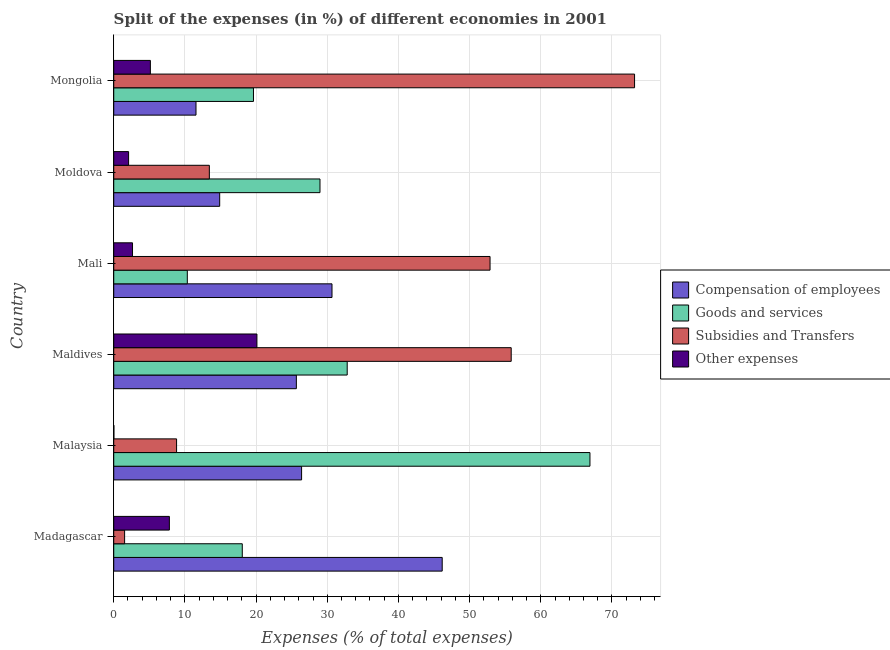How many different coloured bars are there?
Make the answer very short. 4. Are the number of bars per tick equal to the number of legend labels?
Your answer should be compact. Yes. Are the number of bars on each tick of the Y-axis equal?
Offer a terse response. Yes. How many bars are there on the 4th tick from the bottom?
Ensure brevity in your answer.  4. What is the label of the 6th group of bars from the top?
Your answer should be very brief. Madagascar. What is the percentage of amount spent on other expenses in Moldova?
Provide a short and direct response. 2.09. Across all countries, what is the maximum percentage of amount spent on subsidies?
Your answer should be compact. 73.17. Across all countries, what is the minimum percentage of amount spent on goods and services?
Keep it short and to the point. 10.34. In which country was the percentage of amount spent on goods and services maximum?
Make the answer very short. Malaysia. In which country was the percentage of amount spent on other expenses minimum?
Keep it short and to the point. Malaysia. What is the total percentage of amount spent on compensation of employees in the graph?
Keep it short and to the point. 155.3. What is the difference between the percentage of amount spent on goods and services in Malaysia and that in Mali?
Offer a very short reply. 56.57. What is the difference between the percentage of amount spent on other expenses in Malaysia and the percentage of amount spent on subsidies in Maldives?
Ensure brevity in your answer.  -55.82. What is the average percentage of amount spent on other expenses per country?
Your response must be concise. 6.3. What is the difference between the percentage of amount spent on compensation of employees and percentage of amount spent on subsidies in Maldives?
Keep it short and to the point. -30.18. What is the ratio of the percentage of amount spent on goods and services in Maldives to that in Mongolia?
Offer a very short reply. 1.67. Is the difference between the percentage of amount spent on compensation of employees in Madagascar and Mongolia greater than the difference between the percentage of amount spent on goods and services in Madagascar and Mongolia?
Keep it short and to the point. Yes. What is the difference between the highest and the second highest percentage of amount spent on compensation of employees?
Your response must be concise. 15.48. What is the difference between the highest and the lowest percentage of amount spent on compensation of employees?
Your answer should be very brief. 34.59. What does the 3rd bar from the top in Maldives represents?
Your answer should be very brief. Goods and services. What does the 4th bar from the bottom in Maldives represents?
Provide a succinct answer. Other expenses. Are all the bars in the graph horizontal?
Your answer should be compact. Yes. Are the values on the major ticks of X-axis written in scientific E-notation?
Provide a short and direct response. No. Where does the legend appear in the graph?
Your answer should be compact. Center right. How are the legend labels stacked?
Provide a short and direct response. Vertical. What is the title of the graph?
Your answer should be very brief. Split of the expenses (in %) of different economies in 2001. Does "Water" appear as one of the legend labels in the graph?
Give a very brief answer. No. What is the label or title of the X-axis?
Give a very brief answer. Expenses (% of total expenses). What is the Expenses (% of total expenses) of Compensation of employees in Madagascar?
Your answer should be compact. 46.15. What is the Expenses (% of total expenses) of Goods and services in Madagascar?
Provide a succinct answer. 18.06. What is the Expenses (% of total expenses) in Subsidies and Transfers in Madagascar?
Offer a terse response. 1.53. What is the Expenses (% of total expenses) in Other expenses in Madagascar?
Offer a terse response. 7.82. What is the Expenses (% of total expenses) in Compensation of employees in Malaysia?
Make the answer very short. 26.39. What is the Expenses (% of total expenses) in Goods and services in Malaysia?
Offer a very short reply. 66.91. What is the Expenses (% of total expenses) of Subsidies and Transfers in Malaysia?
Ensure brevity in your answer.  8.83. What is the Expenses (% of total expenses) of Other expenses in Malaysia?
Offer a terse response. 0.02. What is the Expenses (% of total expenses) in Compensation of employees in Maldives?
Provide a short and direct response. 25.66. What is the Expenses (% of total expenses) of Goods and services in Maldives?
Offer a very short reply. 32.8. What is the Expenses (% of total expenses) in Subsidies and Transfers in Maldives?
Provide a short and direct response. 55.84. What is the Expenses (% of total expenses) in Other expenses in Maldives?
Your answer should be compact. 20.12. What is the Expenses (% of total expenses) in Compensation of employees in Mali?
Ensure brevity in your answer.  30.66. What is the Expenses (% of total expenses) of Goods and services in Mali?
Make the answer very short. 10.34. What is the Expenses (% of total expenses) in Subsidies and Transfers in Mali?
Your answer should be compact. 52.87. What is the Expenses (% of total expenses) in Other expenses in Mali?
Offer a terse response. 2.64. What is the Expenses (% of total expenses) in Compensation of employees in Moldova?
Your response must be concise. 14.89. What is the Expenses (% of total expenses) in Goods and services in Moldova?
Your response must be concise. 28.98. What is the Expenses (% of total expenses) in Subsidies and Transfers in Moldova?
Keep it short and to the point. 13.43. What is the Expenses (% of total expenses) of Other expenses in Moldova?
Your response must be concise. 2.09. What is the Expenses (% of total expenses) of Compensation of employees in Mongolia?
Make the answer very short. 11.56. What is the Expenses (% of total expenses) in Goods and services in Mongolia?
Make the answer very short. 19.63. What is the Expenses (% of total expenses) in Subsidies and Transfers in Mongolia?
Your answer should be very brief. 73.17. What is the Expenses (% of total expenses) in Other expenses in Mongolia?
Your response must be concise. 5.15. Across all countries, what is the maximum Expenses (% of total expenses) in Compensation of employees?
Provide a short and direct response. 46.15. Across all countries, what is the maximum Expenses (% of total expenses) of Goods and services?
Your answer should be very brief. 66.91. Across all countries, what is the maximum Expenses (% of total expenses) in Subsidies and Transfers?
Your answer should be compact. 73.17. Across all countries, what is the maximum Expenses (% of total expenses) of Other expenses?
Offer a very short reply. 20.12. Across all countries, what is the minimum Expenses (% of total expenses) in Compensation of employees?
Offer a very short reply. 11.56. Across all countries, what is the minimum Expenses (% of total expenses) in Goods and services?
Your answer should be very brief. 10.34. Across all countries, what is the minimum Expenses (% of total expenses) in Subsidies and Transfers?
Offer a very short reply. 1.53. Across all countries, what is the minimum Expenses (% of total expenses) of Other expenses?
Provide a short and direct response. 0.02. What is the total Expenses (% of total expenses) in Compensation of employees in the graph?
Keep it short and to the point. 155.3. What is the total Expenses (% of total expenses) in Goods and services in the graph?
Give a very brief answer. 176.71. What is the total Expenses (% of total expenses) of Subsidies and Transfers in the graph?
Keep it short and to the point. 205.67. What is the total Expenses (% of total expenses) of Other expenses in the graph?
Offer a terse response. 37.82. What is the difference between the Expenses (% of total expenses) in Compensation of employees in Madagascar and that in Malaysia?
Provide a succinct answer. 19.76. What is the difference between the Expenses (% of total expenses) in Goods and services in Madagascar and that in Malaysia?
Offer a very short reply. -48.85. What is the difference between the Expenses (% of total expenses) of Subsidies and Transfers in Madagascar and that in Malaysia?
Offer a very short reply. -7.3. What is the difference between the Expenses (% of total expenses) of Other expenses in Madagascar and that in Malaysia?
Keep it short and to the point. 7.8. What is the difference between the Expenses (% of total expenses) of Compensation of employees in Madagascar and that in Maldives?
Your response must be concise. 20.49. What is the difference between the Expenses (% of total expenses) in Goods and services in Madagascar and that in Maldives?
Make the answer very short. -14.74. What is the difference between the Expenses (% of total expenses) in Subsidies and Transfers in Madagascar and that in Maldives?
Provide a succinct answer. -54.31. What is the difference between the Expenses (% of total expenses) of Other expenses in Madagascar and that in Maldives?
Make the answer very short. -12.3. What is the difference between the Expenses (% of total expenses) of Compensation of employees in Madagascar and that in Mali?
Offer a terse response. 15.48. What is the difference between the Expenses (% of total expenses) of Goods and services in Madagascar and that in Mali?
Offer a terse response. 7.72. What is the difference between the Expenses (% of total expenses) in Subsidies and Transfers in Madagascar and that in Mali?
Offer a very short reply. -51.34. What is the difference between the Expenses (% of total expenses) in Other expenses in Madagascar and that in Mali?
Offer a terse response. 5.18. What is the difference between the Expenses (% of total expenses) in Compensation of employees in Madagascar and that in Moldova?
Provide a short and direct response. 31.26. What is the difference between the Expenses (% of total expenses) in Goods and services in Madagascar and that in Moldova?
Ensure brevity in your answer.  -10.92. What is the difference between the Expenses (% of total expenses) in Subsidies and Transfers in Madagascar and that in Moldova?
Your answer should be very brief. -11.9. What is the difference between the Expenses (% of total expenses) in Other expenses in Madagascar and that in Moldova?
Your answer should be very brief. 5.73. What is the difference between the Expenses (% of total expenses) in Compensation of employees in Madagascar and that in Mongolia?
Provide a short and direct response. 34.59. What is the difference between the Expenses (% of total expenses) in Goods and services in Madagascar and that in Mongolia?
Keep it short and to the point. -1.57. What is the difference between the Expenses (% of total expenses) of Subsidies and Transfers in Madagascar and that in Mongolia?
Ensure brevity in your answer.  -71.65. What is the difference between the Expenses (% of total expenses) in Other expenses in Madagascar and that in Mongolia?
Ensure brevity in your answer.  2.67. What is the difference between the Expenses (% of total expenses) of Compensation of employees in Malaysia and that in Maldives?
Give a very brief answer. 0.73. What is the difference between the Expenses (% of total expenses) in Goods and services in Malaysia and that in Maldives?
Keep it short and to the point. 34.1. What is the difference between the Expenses (% of total expenses) of Subsidies and Transfers in Malaysia and that in Maldives?
Your response must be concise. -47.01. What is the difference between the Expenses (% of total expenses) of Other expenses in Malaysia and that in Maldives?
Your answer should be compact. -20.1. What is the difference between the Expenses (% of total expenses) of Compensation of employees in Malaysia and that in Mali?
Provide a succinct answer. -4.27. What is the difference between the Expenses (% of total expenses) of Goods and services in Malaysia and that in Mali?
Offer a terse response. 56.57. What is the difference between the Expenses (% of total expenses) in Subsidies and Transfers in Malaysia and that in Mali?
Provide a short and direct response. -44.04. What is the difference between the Expenses (% of total expenses) of Other expenses in Malaysia and that in Mali?
Keep it short and to the point. -2.62. What is the difference between the Expenses (% of total expenses) of Compensation of employees in Malaysia and that in Moldova?
Your answer should be very brief. 11.51. What is the difference between the Expenses (% of total expenses) of Goods and services in Malaysia and that in Moldova?
Provide a short and direct response. 37.93. What is the difference between the Expenses (% of total expenses) of Subsidies and Transfers in Malaysia and that in Moldova?
Your response must be concise. -4.6. What is the difference between the Expenses (% of total expenses) in Other expenses in Malaysia and that in Moldova?
Your answer should be compact. -2.07. What is the difference between the Expenses (% of total expenses) in Compensation of employees in Malaysia and that in Mongolia?
Provide a succinct answer. 14.83. What is the difference between the Expenses (% of total expenses) in Goods and services in Malaysia and that in Mongolia?
Give a very brief answer. 47.27. What is the difference between the Expenses (% of total expenses) of Subsidies and Transfers in Malaysia and that in Mongolia?
Provide a short and direct response. -64.35. What is the difference between the Expenses (% of total expenses) of Other expenses in Malaysia and that in Mongolia?
Make the answer very short. -5.13. What is the difference between the Expenses (% of total expenses) in Compensation of employees in Maldives and that in Mali?
Keep it short and to the point. -5.01. What is the difference between the Expenses (% of total expenses) in Goods and services in Maldives and that in Mali?
Keep it short and to the point. 22.47. What is the difference between the Expenses (% of total expenses) of Subsidies and Transfers in Maldives and that in Mali?
Ensure brevity in your answer.  2.97. What is the difference between the Expenses (% of total expenses) in Other expenses in Maldives and that in Mali?
Keep it short and to the point. 17.48. What is the difference between the Expenses (% of total expenses) of Compensation of employees in Maldives and that in Moldova?
Keep it short and to the point. 10.77. What is the difference between the Expenses (% of total expenses) in Goods and services in Maldives and that in Moldova?
Provide a short and direct response. 3.83. What is the difference between the Expenses (% of total expenses) of Subsidies and Transfers in Maldives and that in Moldova?
Ensure brevity in your answer.  42.41. What is the difference between the Expenses (% of total expenses) of Other expenses in Maldives and that in Moldova?
Give a very brief answer. 18.03. What is the difference between the Expenses (% of total expenses) of Compensation of employees in Maldives and that in Mongolia?
Provide a short and direct response. 14.1. What is the difference between the Expenses (% of total expenses) in Goods and services in Maldives and that in Mongolia?
Ensure brevity in your answer.  13.17. What is the difference between the Expenses (% of total expenses) in Subsidies and Transfers in Maldives and that in Mongolia?
Your answer should be compact. -17.33. What is the difference between the Expenses (% of total expenses) of Other expenses in Maldives and that in Mongolia?
Provide a short and direct response. 14.97. What is the difference between the Expenses (% of total expenses) of Compensation of employees in Mali and that in Moldova?
Your response must be concise. 15.78. What is the difference between the Expenses (% of total expenses) in Goods and services in Mali and that in Moldova?
Your answer should be very brief. -18.64. What is the difference between the Expenses (% of total expenses) in Subsidies and Transfers in Mali and that in Moldova?
Offer a very short reply. 39.44. What is the difference between the Expenses (% of total expenses) in Other expenses in Mali and that in Moldova?
Give a very brief answer. 0.55. What is the difference between the Expenses (% of total expenses) in Compensation of employees in Mali and that in Mongolia?
Make the answer very short. 19.11. What is the difference between the Expenses (% of total expenses) in Goods and services in Mali and that in Mongolia?
Keep it short and to the point. -9.3. What is the difference between the Expenses (% of total expenses) of Subsidies and Transfers in Mali and that in Mongolia?
Give a very brief answer. -20.3. What is the difference between the Expenses (% of total expenses) in Other expenses in Mali and that in Mongolia?
Your answer should be compact. -2.51. What is the difference between the Expenses (% of total expenses) of Compensation of employees in Moldova and that in Mongolia?
Ensure brevity in your answer.  3.33. What is the difference between the Expenses (% of total expenses) of Goods and services in Moldova and that in Mongolia?
Provide a succinct answer. 9.34. What is the difference between the Expenses (% of total expenses) in Subsidies and Transfers in Moldova and that in Mongolia?
Ensure brevity in your answer.  -59.74. What is the difference between the Expenses (% of total expenses) of Other expenses in Moldova and that in Mongolia?
Your response must be concise. -3.06. What is the difference between the Expenses (% of total expenses) of Compensation of employees in Madagascar and the Expenses (% of total expenses) of Goods and services in Malaysia?
Give a very brief answer. -20.76. What is the difference between the Expenses (% of total expenses) in Compensation of employees in Madagascar and the Expenses (% of total expenses) in Subsidies and Transfers in Malaysia?
Provide a short and direct response. 37.32. What is the difference between the Expenses (% of total expenses) of Compensation of employees in Madagascar and the Expenses (% of total expenses) of Other expenses in Malaysia?
Ensure brevity in your answer.  46.13. What is the difference between the Expenses (% of total expenses) of Goods and services in Madagascar and the Expenses (% of total expenses) of Subsidies and Transfers in Malaysia?
Your answer should be very brief. 9.23. What is the difference between the Expenses (% of total expenses) in Goods and services in Madagascar and the Expenses (% of total expenses) in Other expenses in Malaysia?
Your answer should be compact. 18.04. What is the difference between the Expenses (% of total expenses) in Subsidies and Transfers in Madagascar and the Expenses (% of total expenses) in Other expenses in Malaysia?
Offer a very short reply. 1.51. What is the difference between the Expenses (% of total expenses) of Compensation of employees in Madagascar and the Expenses (% of total expenses) of Goods and services in Maldives?
Provide a short and direct response. 13.35. What is the difference between the Expenses (% of total expenses) in Compensation of employees in Madagascar and the Expenses (% of total expenses) in Subsidies and Transfers in Maldives?
Give a very brief answer. -9.69. What is the difference between the Expenses (% of total expenses) of Compensation of employees in Madagascar and the Expenses (% of total expenses) of Other expenses in Maldives?
Offer a terse response. 26.03. What is the difference between the Expenses (% of total expenses) in Goods and services in Madagascar and the Expenses (% of total expenses) in Subsidies and Transfers in Maldives?
Offer a very short reply. -37.78. What is the difference between the Expenses (% of total expenses) in Goods and services in Madagascar and the Expenses (% of total expenses) in Other expenses in Maldives?
Your answer should be compact. -2.06. What is the difference between the Expenses (% of total expenses) in Subsidies and Transfers in Madagascar and the Expenses (% of total expenses) in Other expenses in Maldives?
Your response must be concise. -18.59. What is the difference between the Expenses (% of total expenses) in Compensation of employees in Madagascar and the Expenses (% of total expenses) in Goods and services in Mali?
Your answer should be very brief. 35.81. What is the difference between the Expenses (% of total expenses) in Compensation of employees in Madagascar and the Expenses (% of total expenses) in Subsidies and Transfers in Mali?
Offer a terse response. -6.72. What is the difference between the Expenses (% of total expenses) in Compensation of employees in Madagascar and the Expenses (% of total expenses) in Other expenses in Mali?
Your response must be concise. 43.51. What is the difference between the Expenses (% of total expenses) of Goods and services in Madagascar and the Expenses (% of total expenses) of Subsidies and Transfers in Mali?
Offer a very short reply. -34.81. What is the difference between the Expenses (% of total expenses) in Goods and services in Madagascar and the Expenses (% of total expenses) in Other expenses in Mali?
Provide a succinct answer. 15.42. What is the difference between the Expenses (% of total expenses) in Subsidies and Transfers in Madagascar and the Expenses (% of total expenses) in Other expenses in Mali?
Offer a terse response. -1.11. What is the difference between the Expenses (% of total expenses) in Compensation of employees in Madagascar and the Expenses (% of total expenses) in Goods and services in Moldova?
Your answer should be very brief. 17.17. What is the difference between the Expenses (% of total expenses) in Compensation of employees in Madagascar and the Expenses (% of total expenses) in Subsidies and Transfers in Moldova?
Keep it short and to the point. 32.72. What is the difference between the Expenses (% of total expenses) of Compensation of employees in Madagascar and the Expenses (% of total expenses) of Other expenses in Moldova?
Provide a short and direct response. 44.06. What is the difference between the Expenses (% of total expenses) in Goods and services in Madagascar and the Expenses (% of total expenses) in Subsidies and Transfers in Moldova?
Your answer should be compact. 4.63. What is the difference between the Expenses (% of total expenses) of Goods and services in Madagascar and the Expenses (% of total expenses) of Other expenses in Moldova?
Keep it short and to the point. 15.97. What is the difference between the Expenses (% of total expenses) of Subsidies and Transfers in Madagascar and the Expenses (% of total expenses) of Other expenses in Moldova?
Provide a succinct answer. -0.56. What is the difference between the Expenses (% of total expenses) in Compensation of employees in Madagascar and the Expenses (% of total expenses) in Goods and services in Mongolia?
Offer a very short reply. 26.52. What is the difference between the Expenses (% of total expenses) in Compensation of employees in Madagascar and the Expenses (% of total expenses) in Subsidies and Transfers in Mongolia?
Your answer should be very brief. -27.03. What is the difference between the Expenses (% of total expenses) of Compensation of employees in Madagascar and the Expenses (% of total expenses) of Other expenses in Mongolia?
Keep it short and to the point. 41. What is the difference between the Expenses (% of total expenses) of Goods and services in Madagascar and the Expenses (% of total expenses) of Subsidies and Transfers in Mongolia?
Ensure brevity in your answer.  -55.11. What is the difference between the Expenses (% of total expenses) in Goods and services in Madagascar and the Expenses (% of total expenses) in Other expenses in Mongolia?
Provide a succinct answer. 12.91. What is the difference between the Expenses (% of total expenses) in Subsidies and Transfers in Madagascar and the Expenses (% of total expenses) in Other expenses in Mongolia?
Offer a very short reply. -3.62. What is the difference between the Expenses (% of total expenses) in Compensation of employees in Malaysia and the Expenses (% of total expenses) in Goods and services in Maldives?
Offer a terse response. -6.41. What is the difference between the Expenses (% of total expenses) in Compensation of employees in Malaysia and the Expenses (% of total expenses) in Subsidies and Transfers in Maldives?
Ensure brevity in your answer.  -29.45. What is the difference between the Expenses (% of total expenses) of Compensation of employees in Malaysia and the Expenses (% of total expenses) of Other expenses in Maldives?
Your answer should be compact. 6.28. What is the difference between the Expenses (% of total expenses) of Goods and services in Malaysia and the Expenses (% of total expenses) of Subsidies and Transfers in Maldives?
Make the answer very short. 11.07. What is the difference between the Expenses (% of total expenses) in Goods and services in Malaysia and the Expenses (% of total expenses) in Other expenses in Maldives?
Your answer should be compact. 46.79. What is the difference between the Expenses (% of total expenses) of Subsidies and Transfers in Malaysia and the Expenses (% of total expenses) of Other expenses in Maldives?
Keep it short and to the point. -11.29. What is the difference between the Expenses (% of total expenses) in Compensation of employees in Malaysia and the Expenses (% of total expenses) in Goods and services in Mali?
Keep it short and to the point. 16.06. What is the difference between the Expenses (% of total expenses) in Compensation of employees in Malaysia and the Expenses (% of total expenses) in Subsidies and Transfers in Mali?
Give a very brief answer. -26.48. What is the difference between the Expenses (% of total expenses) in Compensation of employees in Malaysia and the Expenses (% of total expenses) in Other expenses in Mali?
Offer a very short reply. 23.75. What is the difference between the Expenses (% of total expenses) of Goods and services in Malaysia and the Expenses (% of total expenses) of Subsidies and Transfers in Mali?
Provide a succinct answer. 14.04. What is the difference between the Expenses (% of total expenses) of Goods and services in Malaysia and the Expenses (% of total expenses) of Other expenses in Mali?
Your answer should be compact. 64.27. What is the difference between the Expenses (% of total expenses) of Subsidies and Transfers in Malaysia and the Expenses (% of total expenses) of Other expenses in Mali?
Give a very brief answer. 6.19. What is the difference between the Expenses (% of total expenses) in Compensation of employees in Malaysia and the Expenses (% of total expenses) in Goods and services in Moldova?
Ensure brevity in your answer.  -2.58. What is the difference between the Expenses (% of total expenses) in Compensation of employees in Malaysia and the Expenses (% of total expenses) in Subsidies and Transfers in Moldova?
Make the answer very short. 12.96. What is the difference between the Expenses (% of total expenses) in Compensation of employees in Malaysia and the Expenses (% of total expenses) in Other expenses in Moldova?
Your response must be concise. 24.31. What is the difference between the Expenses (% of total expenses) of Goods and services in Malaysia and the Expenses (% of total expenses) of Subsidies and Transfers in Moldova?
Your answer should be compact. 53.48. What is the difference between the Expenses (% of total expenses) of Goods and services in Malaysia and the Expenses (% of total expenses) of Other expenses in Moldova?
Your response must be concise. 64.82. What is the difference between the Expenses (% of total expenses) of Subsidies and Transfers in Malaysia and the Expenses (% of total expenses) of Other expenses in Moldova?
Your answer should be compact. 6.74. What is the difference between the Expenses (% of total expenses) of Compensation of employees in Malaysia and the Expenses (% of total expenses) of Goods and services in Mongolia?
Your answer should be very brief. 6.76. What is the difference between the Expenses (% of total expenses) of Compensation of employees in Malaysia and the Expenses (% of total expenses) of Subsidies and Transfers in Mongolia?
Your response must be concise. -46.78. What is the difference between the Expenses (% of total expenses) in Compensation of employees in Malaysia and the Expenses (% of total expenses) in Other expenses in Mongolia?
Offer a very short reply. 21.24. What is the difference between the Expenses (% of total expenses) in Goods and services in Malaysia and the Expenses (% of total expenses) in Subsidies and Transfers in Mongolia?
Your answer should be very brief. -6.27. What is the difference between the Expenses (% of total expenses) of Goods and services in Malaysia and the Expenses (% of total expenses) of Other expenses in Mongolia?
Give a very brief answer. 61.76. What is the difference between the Expenses (% of total expenses) in Subsidies and Transfers in Malaysia and the Expenses (% of total expenses) in Other expenses in Mongolia?
Keep it short and to the point. 3.68. What is the difference between the Expenses (% of total expenses) in Compensation of employees in Maldives and the Expenses (% of total expenses) in Goods and services in Mali?
Your answer should be compact. 15.32. What is the difference between the Expenses (% of total expenses) in Compensation of employees in Maldives and the Expenses (% of total expenses) in Subsidies and Transfers in Mali?
Offer a very short reply. -27.21. What is the difference between the Expenses (% of total expenses) in Compensation of employees in Maldives and the Expenses (% of total expenses) in Other expenses in Mali?
Your answer should be compact. 23.02. What is the difference between the Expenses (% of total expenses) in Goods and services in Maldives and the Expenses (% of total expenses) in Subsidies and Transfers in Mali?
Give a very brief answer. -20.07. What is the difference between the Expenses (% of total expenses) of Goods and services in Maldives and the Expenses (% of total expenses) of Other expenses in Mali?
Offer a very short reply. 30.16. What is the difference between the Expenses (% of total expenses) of Subsidies and Transfers in Maldives and the Expenses (% of total expenses) of Other expenses in Mali?
Your answer should be compact. 53.2. What is the difference between the Expenses (% of total expenses) in Compensation of employees in Maldives and the Expenses (% of total expenses) in Goods and services in Moldova?
Offer a terse response. -3.32. What is the difference between the Expenses (% of total expenses) in Compensation of employees in Maldives and the Expenses (% of total expenses) in Subsidies and Transfers in Moldova?
Your answer should be compact. 12.23. What is the difference between the Expenses (% of total expenses) of Compensation of employees in Maldives and the Expenses (% of total expenses) of Other expenses in Moldova?
Your answer should be very brief. 23.57. What is the difference between the Expenses (% of total expenses) in Goods and services in Maldives and the Expenses (% of total expenses) in Subsidies and Transfers in Moldova?
Offer a very short reply. 19.37. What is the difference between the Expenses (% of total expenses) in Goods and services in Maldives and the Expenses (% of total expenses) in Other expenses in Moldova?
Make the answer very short. 30.72. What is the difference between the Expenses (% of total expenses) in Subsidies and Transfers in Maldives and the Expenses (% of total expenses) in Other expenses in Moldova?
Offer a very short reply. 53.76. What is the difference between the Expenses (% of total expenses) of Compensation of employees in Maldives and the Expenses (% of total expenses) of Goods and services in Mongolia?
Your response must be concise. 6.02. What is the difference between the Expenses (% of total expenses) in Compensation of employees in Maldives and the Expenses (% of total expenses) in Subsidies and Transfers in Mongolia?
Keep it short and to the point. -47.52. What is the difference between the Expenses (% of total expenses) in Compensation of employees in Maldives and the Expenses (% of total expenses) in Other expenses in Mongolia?
Provide a succinct answer. 20.51. What is the difference between the Expenses (% of total expenses) in Goods and services in Maldives and the Expenses (% of total expenses) in Subsidies and Transfers in Mongolia?
Your answer should be very brief. -40.37. What is the difference between the Expenses (% of total expenses) of Goods and services in Maldives and the Expenses (% of total expenses) of Other expenses in Mongolia?
Ensure brevity in your answer.  27.65. What is the difference between the Expenses (% of total expenses) of Subsidies and Transfers in Maldives and the Expenses (% of total expenses) of Other expenses in Mongolia?
Your response must be concise. 50.69. What is the difference between the Expenses (% of total expenses) of Compensation of employees in Mali and the Expenses (% of total expenses) of Goods and services in Moldova?
Offer a terse response. 1.69. What is the difference between the Expenses (% of total expenses) in Compensation of employees in Mali and the Expenses (% of total expenses) in Subsidies and Transfers in Moldova?
Ensure brevity in your answer.  17.23. What is the difference between the Expenses (% of total expenses) in Compensation of employees in Mali and the Expenses (% of total expenses) in Other expenses in Moldova?
Your answer should be compact. 28.58. What is the difference between the Expenses (% of total expenses) in Goods and services in Mali and the Expenses (% of total expenses) in Subsidies and Transfers in Moldova?
Your answer should be very brief. -3.1. What is the difference between the Expenses (% of total expenses) in Goods and services in Mali and the Expenses (% of total expenses) in Other expenses in Moldova?
Your answer should be very brief. 8.25. What is the difference between the Expenses (% of total expenses) of Subsidies and Transfers in Mali and the Expenses (% of total expenses) of Other expenses in Moldova?
Offer a very short reply. 50.78. What is the difference between the Expenses (% of total expenses) of Compensation of employees in Mali and the Expenses (% of total expenses) of Goods and services in Mongolia?
Make the answer very short. 11.03. What is the difference between the Expenses (% of total expenses) in Compensation of employees in Mali and the Expenses (% of total expenses) in Subsidies and Transfers in Mongolia?
Ensure brevity in your answer.  -42.51. What is the difference between the Expenses (% of total expenses) of Compensation of employees in Mali and the Expenses (% of total expenses) of Other expenses in Mongolia?
Give a very brief answer. 25.52. What is the difference between the Expenses (% of total expenses) in Goods and services in Mali and the Expenses (% of total expenses) in Subsidies and Transfers in Mongolia?
Provide a short and direct response. -62.84. What is the difference between the Expenses (% of total expenses) of Goods and services in Mali and the Expenses (% of total expenses) of Other expenses in Mongolia?
Your response must be concise. 5.19. What is the difference between the Expenses (% of total expenses) of Subsidies and Transfers in Mali and the Expenses (% of total expenses) of Other expenses in Mongolia?
Offer a very short reply. 47.72. What is the difference between the Expenses (% of total expenses) of Compensation of employees in Moldova and the Expenses (% of total expenses) of Goods and services in Mongolia?
Provide a succinct answer. -4.75. What is the difference between the Expenses (% of total expenses) of Compensation of employees in Moldova and the Expenses (% of total expenses) of Subsidies and Transfers in Mongolia?
Offer a very short reply. -58.29. What is the difference between the Expenses (% of total expenses) in Compensation of employees in Moldova and the Expenses (% of total expenses) in Other expenses in Mongolia?
Your response must be concise. 9.74. What is the difference between the Expenses (% of total expenses) in Goods and services in Moldova and the Expenses (% of total expenses) in Subsidies and Transfers in Mongolia?
Provide a short and direct response. -44.2. What is the difference between the Expenses (% of total expenses) in Goods and services in Moldova and the Expenses (% of total expenses) in Other expenses in Mongolia?
Your response must be concise. 23.83. What is the difference between the Expenses (% of total expenses) in Subsidies and Transfers in Moldova and the Expenses (% of total expenses) in Other expenses in Mongolia?
Offer a terse response. 8.28. What is the average Expenses (% of total expenses) of Compensation of employees per country?
Your response must be concise. 25.88. What is the average Expenses (% of total expenses) in Goods and services per country?
Your response must be concise. 29.45. What is the average Expenses (% of total expenses) in Subsidies and Transfers per country?
Your answer should be very brief. 34.28. What is the average Expenses (% of total expenses) of Other expenses per country?
Keep it short and to the point. 6.3. What is the difference between the Expenses (% of total expenses) of Compensation of employees and Expenses (% of total expenses) of Goods and services in Madagascar?
Make the answer very short. 28.09. What is the difference between the Expenses (% of total expenses) of Compensation of employees and Expenses (% of total expenses) of Subsidies and Transfers in Madagascar?
Give a very brief answer. 44.62. What is the difference between the Expenses (% of total expenses) of Compensation of employees and Expenses (% of total expenses) of Other expenses in Madagascar?
Provide a succinct answer. 38.33. What is the difference between the Expenses (% of total expenses) of Goods and services and Expenses (% of total expenses) of Subsidies and Transfers in Madagascar?
Provide a short and direct response. 16.53. What is the difference between the Expenses (% of total expenses) of Goods and services and Expenses (% of total expenses) of Other expenses in Madagascar?
Provide a short and direct response. 10.24. What is the difference between the Expenses (% of total expenses) of Subsidies and Transfers and Expenses (% of total expenses) of Other expenses in Madagascar?
Provide a short and direct response. -6.29. What is the difference between the Expenses (% of total expenses) in Compensation of employees and Expenses (% of total expenses) in Goods and services in Malaysia?
Offer a terse response. -40.51. What is the difference between the Expenses (% of total expenses) in Compensation of employees and Expenses (% of total expenses) in Subsidies and Transfers in Malaysia?
Your answer should be compact. 17.56. What is the difference between the Expenses (% of total expenses) of Compensation of employees and Expenses (% of total expenses) of Other expenses in Malaysia?
Offer a very short reply. 26.37. What is the difference between the Expenses (% of total expenses) in Goods and services and Expenses (% of total expenses) in Subsidies and Transfers in Malaysia?
Your answer should be compact. 58.08. What is the difference between the Expenses (% of total expenses) of Goods and services and Expenses (% of total expenses) of Other expenses in Malaysia?
Offer a terse response. 66.89. What is the difference between the Expenses (% of total expenses) of Subsidies and Transfers and Expenses (% of total expenses) of Other expenses in Malaysia?
Make the answer very short. 8.81. What is the difference between the Expenses (% of total expenses) in Compensation of employees and Expenses (% of total expenses) in Goods and services in Maldives?
Provide a succinct answer. -7.14. What is the difference between the Expenses (% of total expenses) of Compensation of employees and Expenses (% of total expenses) of Subsidies and Transfers in Maldives?
Offer a very short reply. -30.18. What is the difference between the Expenses (% of total expenses) of Compensation of employees and Expenses (% of total expenses) of Other expenses in Maldives?
Give a very brief answer. 5.54. What is the difference between the Expenses (% of total expenses) in Goods and services and Expenses (% of total expenses) in Subsidies and Transfers in Maldives?
Offer a terse response. -23.04. What is the difference between the Expenses (% of total expenses) of Goods and services and Expenses (% of total expenses) of Other expenses in Maldives?
Make the answer very short. 12.69. What is the difference between the Expenses (% of total expenses) in Subsidies and Transfers and Expenses (% of total expenses) in Other expenses in Maldives?
Offer a terse response. 35.72. What is the difference between the Expenses (% of total expenses) in Compensation of employees and Expenses (% of total expenses) in Goods and services in Mali?
Your response must be concise. 20.33. What is the difference between the Expenses (% of total expenses) of Compensation of employees and Expenses (% of total expenses) of Subsidies and Transfers in Mali?
Make the answer very short. -22.21. What is the difference between the Expenses (% of total expenses) in Compensation of employees and Expenses (% of total expenses) in Other expenses in Mali?
Your response must be concise. 28.03. What is the difference between the Expenses (% of total expenses) in Goods and services and Expenses (% of total expenses) in Subsidies and Transfers in Mali?
Your answer should be compact. -42.54. What is the difference between the Expenses (% of total expenses) in Goods and services and Expenses (% of total expenses) in Other expenses in Mali?
Offer a terse response. 7.7. What is the difference between the Expenses (% of total expenses) in Subsidies and Transfers and Expenses (% of total expenses) in Other expenses in Mali?
Your answer should be compact. 50.23. What is the difference between the Expenses (% of total expenses) in Compensation of employees and Expenses (% of total expenses) in Goods and services in Moldova?
Keep it short and to the point. -14.09. What is the difference between the Expenses (% of total expenses) of Compensation of employees and Expenses (% of total expenses) of Subsidies and Transfers in Moldova?
Your response must be concise. 1.45. What is the difference between the Expenses (% of total expenses) of Compensation of employees and Expenses (% of total expenses) of Other expenses in Moldova?
Offer a very short reply. 12.8. What is the difference between the Expenses (% of total expenses) in Goods and services and Expenses (% of total expenses) in Subsidies and Transfers in Moldova?
Your answer should be compact. 15.54. What is the difference between the Expenses (% of total expenses) of Goods and services and Expenses (% of total expenses) of Other expenses in Moldova?
Your response must be concise. 26.89. What is the difference between the Expenses (% of total expenses) in Subsidies and Transfers and Expenses (% of total expenses) in Other expenses in Moldova?
Offer a very short reply. 11.35. What is the difference between the Expenses (% of total expenses) in Compensation of employees and Expenses (% of total expenses) in Goods and services in Mongolia?
Give a very brief answer. -8.07. What is the difference between the Expenses (% of total expenses) of Compensation of employees and Expenses (% of total expenses) of Subsidies and Transfers in Mongolia?
Your answer should be very brief. -61.62. What is the difference between the Expenses (% of total expenses) in Compensation of employees and Expenses (% of total expenses) in Other expenses in Mongolia?
Keep it short and to the point. 6.41. What is the difference between the Expenses (% of total expenses) of Goods and services and Expenses (% of total expenses) of Subsidies and Transfers in Mongolia?
Offer a very short reply. -53.54. What is the difference between the Expenses (% of total expenses) in Goods and services and Expenses (% of total expenses) in Other expenses in Mongolia?
Your answer should be very brief. 14.48. What is the difference between the Expenses (% of total expenses) in Subsidies and Transfers and Expenses (% of total expenses) in Other expenses in Mongolia?
Your answer should be compact. 68.03. What is the ratio of the Expenses (% of total expenses) in Compensation of employees in Madagascar to that in Malaysia?
Keep it short and to the point. 1.75. What is the ratio of the Expenses (% of total expenses) of Goods and services in Madagascar to that in Malaysia?
Offer a terse response. 0.27. What is the ratio of the Expenses (% of total expenses) in Subsidies and Transfers in Madagascar to that in Malaysia?
Offer a terse response. 0.17. What is the ratio of the Expenses (% of total expenses) in Other expenses in Madagascar to that in Malaysia?
Give a very brief answer. 397.74. What is the ratio of the Expenses (% of total expenses) of Compensation of employees in Madagascar to that in Maldives?
Provide a succinct answer. 1.8. What is the ratio of the Expenses (% of total expenses) of Goods and services in Madagascar to that in Maldives?
Ensure brevity in your answer.  0.55. What is the ratio of the Expenses (% of total expenses) of Subsidies and Transfers in Madagascar to that in Maldives?
Provide a succinct answer. 0.03. What is the ratio of the Expenses (% of total expenses) in Other expenses in Madagascar to that in Maldives?
Your answer should be very brief. 0.39. What is the ratio of the Expenses (% of total expenses) in Compensation of employees in Madagascar to that in Mali?
Give a very brief answer. 1.5. What is the ratio of the Expenses (% of total expenses) of Goods and services in Madagascar to that in Mali?
Provide a short and direct response. 1.75. What is the ratio of the Expenses (% of total expenses) of Subsidies and Transfers in Madagascar to that in Mali?
Your answer should be compact. 0.03. What is the ratio of the Expenses (% of total expenses) of Other expenses in Madagascar to that in Mali?
Your answer should be very brief. 2.96. What is the ratio of the Expenses (% of total expenses) of Compensation of employees in Madagascar to that in Moldova?
Make the answer very short. 3.1. What is the ratio of the Expenses (% of total expenses) of Goods and services in Madagascar to that in Moldova?
Offer a very short reply. 0.62. What is the ratio of the Expenses (% of total expenses) in Subsidies and Transfers in Madagascar to that in Moldova?
Give a very brief answer. 0.11. What is the ratio of the Expenses (% of total expenses) in Other expenses in Madagascar to that in Moldova?
Offer a very short reply. 3.75. What is the ratio of the Expenses (% of total expenses) of Compensation of employees in Madagascar to that in Mongolia?
Offer a terse response. 3.99. What is the ratio of the Expenses (% of total expenses) in Goods and services in Madagascar to that in Mongolia?
Provide a succinct answer. 0.92. What is the ratio of the Expenses (% of total expenses) of Subsidies and Transfers in Madagascar to that in Mongolia?
Offer a terse response. 0.02. What is the ratio of the Expenses (% of total expenses) in Other expenses in Madagascar to that in Mongolia?
Provide a succinct answer. 1.52. What is the ratio of the Expenses (% of total expenses) in Compensation of employees in Malaysia to that in Maldives?
Make the answer very short. 1.03. What is the ratio of the Expenses (% of total expenses) of Goods and services in Malaysia to that in Maldives?
Offer a very short reply. 2.04. What is the ratio of the Expenses (% of total expenses) in Subsidies and Transfers in Malaysia to that in Maldives?
Give a very brief answer. 0.16. What is the ratio of the Expenses (% of total expenses) of Other expenses in Malaysia to that in Maldives?
Provide a succinct answer. 0. What is the ratio of the Expenses (% of total expenses) in Compensation of employees in Malaysia to that in Mali?
Provide a short and direct response. 0.86. What is the ratio of the Expenses (% of total expenses) in Goods and services in Malaysia to that in Mali?
Provide a succinct answer. 6.47. What is the ratio of the Expenses (% of total expenses) in Subsidies and Transfers in Malaysia to that in Mali?
Provide a short and direct response. 0.17. What is the ratio of the Expenses (% of total expenses) of Other expenses in Malaysia to that in Mali?
Give a very brief answer. 0.01. What is the ratio of the Expenses (% of total expenses) of Compensation of employees in Malaysia to that in Moldova?
Make the answer very short. 1.77. What is the ratio of the Expenses (% of total expenses) in Goods and services in Malaysia to that in Moldova?
Provide a short and direct response. 2.31. What is the ratio of the Expenses (% of total expenses) in Subsidies and Transfers in Malaysia to that in Moldova?
Provide a succinct answer. 0.66. What is the ratio of the Expenses (% of total expenses) of Other expenses in Malaysia to that in Moldova?
Your answer should be very brief. 0.01. What is the ratio of the Expenses (% of total expenses) in Compensation of employees in Malaysia to that in Mongolia?
Offer a terse response. 2.28. What is the ratio of the Expenses (% of total expenses) in Goods and services in Malaysia to that in Mongolia?
Your answer should be compact. 3.41. What is the ratio of the Expenses (% of total expenses) in Subsidies and Transfers in Malaysia to that in Mongolia?
Offer a very short reply. 0.12. What is the ratio of the Expenses (% of total expenses) of Other expenses in Malaysia to that in Mongolia?
Keep it short and to the point. 0. What is the ratio of the Expenses (% of total expenses) in Compensation of employees in Maldives to that in Mali?
Make the answer very short. 0.84. What is the ratio of the Expenses (% of total expenses) of Goods and services in Maldives to that in Mali?
Offer a terse response. 3.17. What is the ratio of the Expenses (% of total expenses) in Subsidies and Transfers in Maldives to that in Mali?
Provide a succinct answer. 1.06. What is the ratio of the Expenses (% of total expenses) of Other expenses in Maldives to that in Mali?
Your response must be concise. 7.62. What is the ratio of the Expenses (% of total expenses) of Compensation of employees in Maldives to that in Moldova?
Your answer should be compact. 1.72. What is the ratio of the Expenses (% of total expenses) of Goods and services in Maldives to that in Moldova?
Ensure brevity in your answer.  1.13. What is the ratio of the Expenses (% of total expenses) of Subsidies and Transfers in Maldives to that in Moldova?
Make the answer very short. 4.16. What is the ratio of the Expenses (% of total expenses) of Other expenses in Maldives to that in Moldova?
Your answer should be compact. 9.64. What is the ratio of the Expenses (% of total expenses) in Compensation of employees in Maldives to that in Mongolia?
Keep it short and to the point. 2.22. What is the ratio of the Expenses (% of total expenses) of Goods and services in Maldives to that in Mongolia?
Give a very brief answer. 1.67. What is the ratio of the Expenses (% of total expenses) of Subsidies and Transfers in Maldives to that in Mongolia?
Make the answer very short. 0.76. What is the ratio of the Expenses (% of total expenses) of Other expenses in Maldives to that in Mongolia?
Give a very brief answer. 3.91. What is the ratio of the Expenses (% of total expenses) in Compensation of employees in Mali to that in Moldova?
Give a very brief answer. 2.06. What is the ratio of the Expenses (% of total expenses) in Goods and services in Mali to that in Moldova?
Provide a succinct answer. 0.36. What is the ratio of the Expenses (% of total expenses) of Subsidies and Transfers in Mali to that in Moldova?
Provide a succinct answer. 3.94. What is the ratio of the Expenses (% of total expenses) in Other expenses in Mali to that in Moldova?
Keep it short and to the point. 1.26. What is the ratio of the Expenses (% of total expenses) of Compensation of employees in Mali to that in Mongolia?
Make the answer very short. 2.65. What is the ratio of the Expenses (% of total expenses) of Goods and services in Mali to that in Mongolia?
Give a very brief answer. 0.53. What is the ratio of the Expenses (% of total expenses) of Subsidies and Transfers in Mali to that in Mongolia?
Provide a succinct answer. 0.72. What is the ratio of the Expenses (% of total expenses) of Other expenses in Mali to that in Mongolia?
Offer a very short reply. 0.51. What is the ratio of the Expenses (% of total expenses) of Compensation of employees in Moldova to that in Mongolia?
Your answer should be compact. 1.29. What is the ratio of the Expenses (% of total expenses) in Goods and services in Moldova to that in Mongolia?
Give a very brief answer. 1.48. What is the ratio of the Expenses (% of total expenses) of Subsidies and Transfers in Moldova to that in Mongolia?
Your answer should be compact. 0.18. What is the ratio of the Expenses (% of total expenses) in Other expenses in Moldova to that in Mongolia?
Make the answer very short. 0.41. What is the difference between the highest and the second highest Expenses (% of total expenses) of Compensation of employees?
Provide a short and direct response. 15.48. What is the difference between the highest and the second highest Expenses (% of total expenses) of Goods and services?
Offer a very short reply. 34.1. What is the difference between the highest and the second highest Expenses (% of total expenses) in Subsidies and Transfers?
Offer a terse response. 17.33. What is the difference between the highest and the second highest Expenses (% of total expenses) of Other expenses?
Make the answer very short. 12.3. What is the difference between the highest and the lowest Expenses (% of total expenses) of Compensation of employees?
Your response must be concise. 34.59. What is the difference between the highest and the lowest Expenses (% of total expenses) in Goods and services?
Your answer should be compact. 56.57. What is the difference between the highest and the lowest Expenses (% of total expenses) in Subsidies and Transfers?
Offer a very short reply. 71.65. What is the difference between the highest and the lowest Expenses (% of total expenses) of Other expenses?
Ensure brevity in your answer.  20.1. 